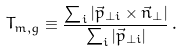Convert formula to latex. <formula><loc_0><loc_0><loc_500><loc_500>T _ { m , g } \equiv \frac { \sum _ { i } | \vec { p } _ { \perp i } \times { \vec { n } _ { \perp } | } } { \sum _ { i } | \vec { p } _ { \perp i } | } \, .</formula> 